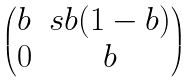Convert formula to latex. <formula><loc_0><loc_0><loc_500><loc_500>\begin{pmatrix} b & s b ( 1 - b ) \\ 0 & b \end{pmatrix}</formula> 